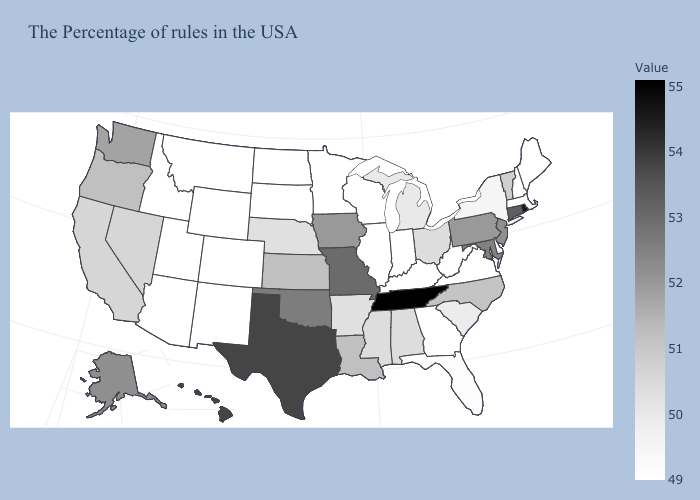Among the states that border Texas , which have the highest value?
Write a very short answer. Oklahoma. Among the states that border Alabama , which have the highest value?
Quick response, please. Tennessee. Which states have the highest value in the USA?
Answer briefly. Tennessee. Among the states that border New Hampshire , which have the lowest value?
Quick response, please. Maine, Massachusetts. Is the legend a continuous bar?
Quick response, please. Yes. 